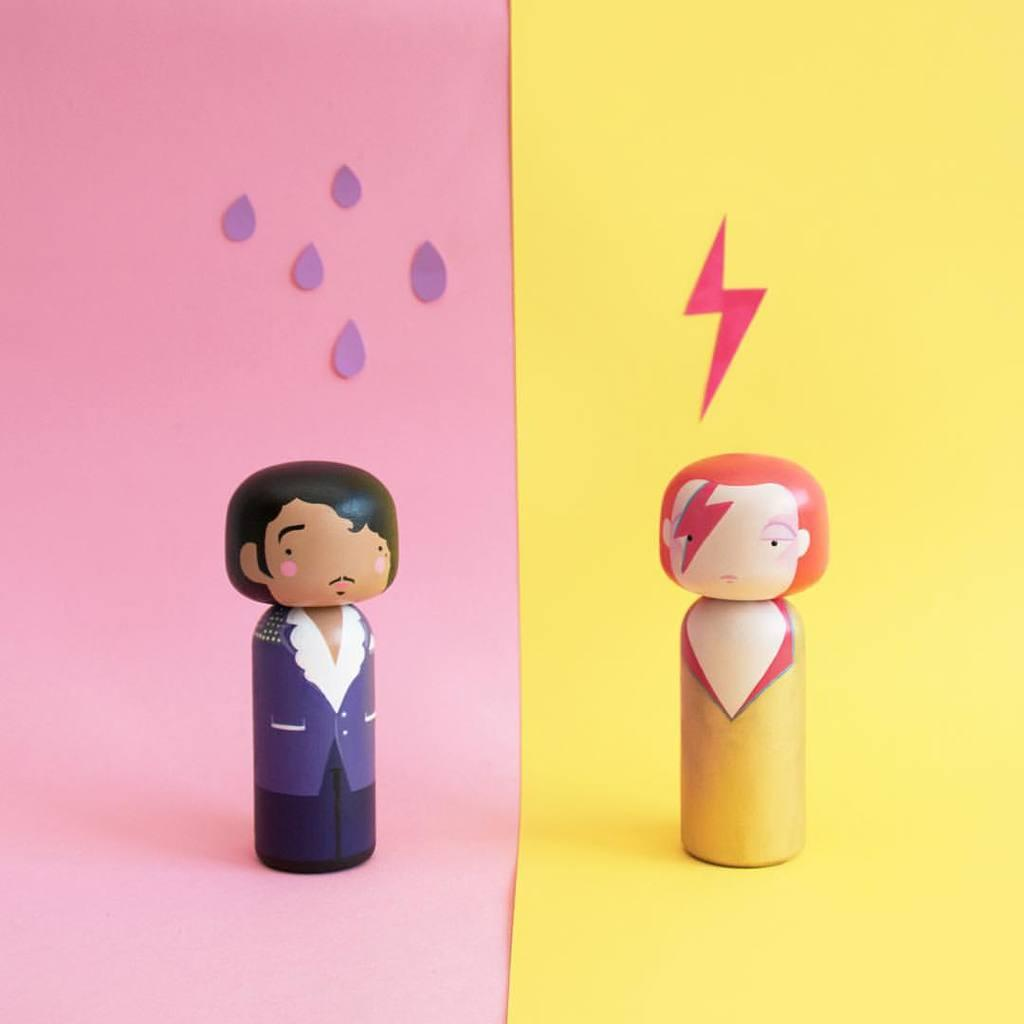How many dolls are present in the image? There are two dolls in the image. Where are the dolls located in the image? The dolls are placed on a surface. What type of mask is the doll wearing in the image? There is no mask present in the image, as it features two dolls placed on a surface. 